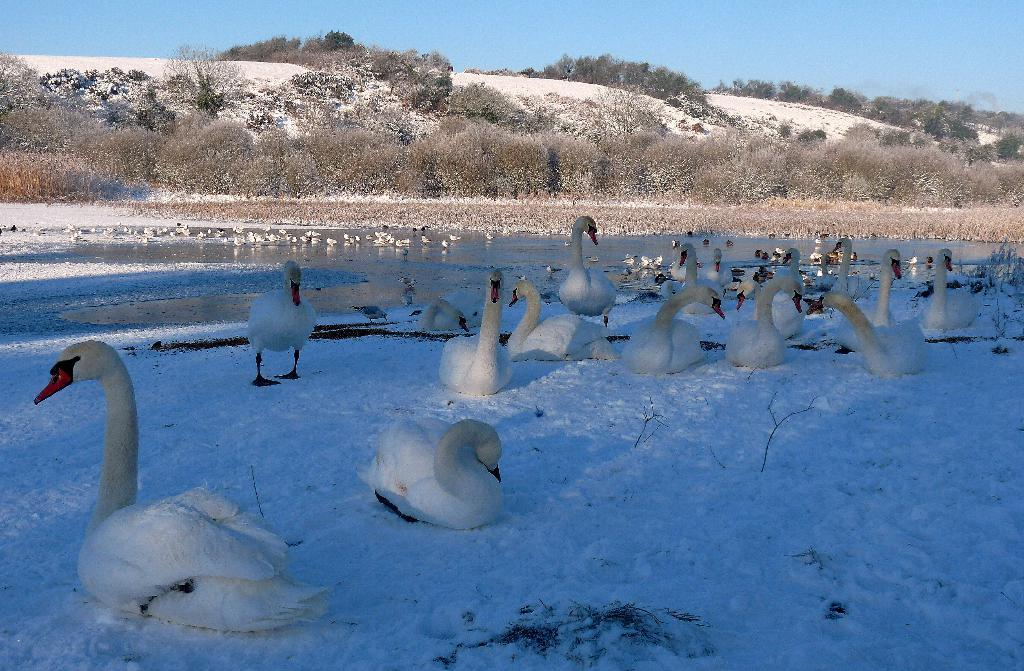What animals can be seen in the snow in the image? There are ducks in the snow in the image. What else can be seen besides the snow and ducks? There is water, trees, and grass visible in the image. What is visible at the top of the image? The sky is visible at the top of the image. What type of peace is being promoted by the ducks in the image? There is no indication in the image that the ducks are promoting any type of peace. 